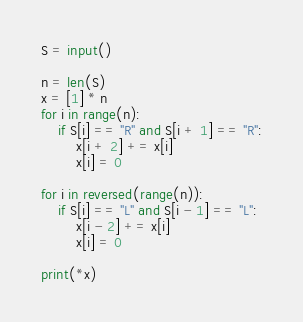<code> <loc_0><loc_0><loc_500><loc_500><_Python_>S = input()

n = len(S)
x = [1] * n
for i in range(n):
    if S[i] == "R" and S[i + 1] == "R":
        x[i + 2] += x[i]
        x[i] = 0

for i in reversed(range(n)):
    if S[i] == "L" and S[i - 1] == "L":
        x[i - 2] += x[i]
        x[i] = 0
            
print(*x)
</code> 